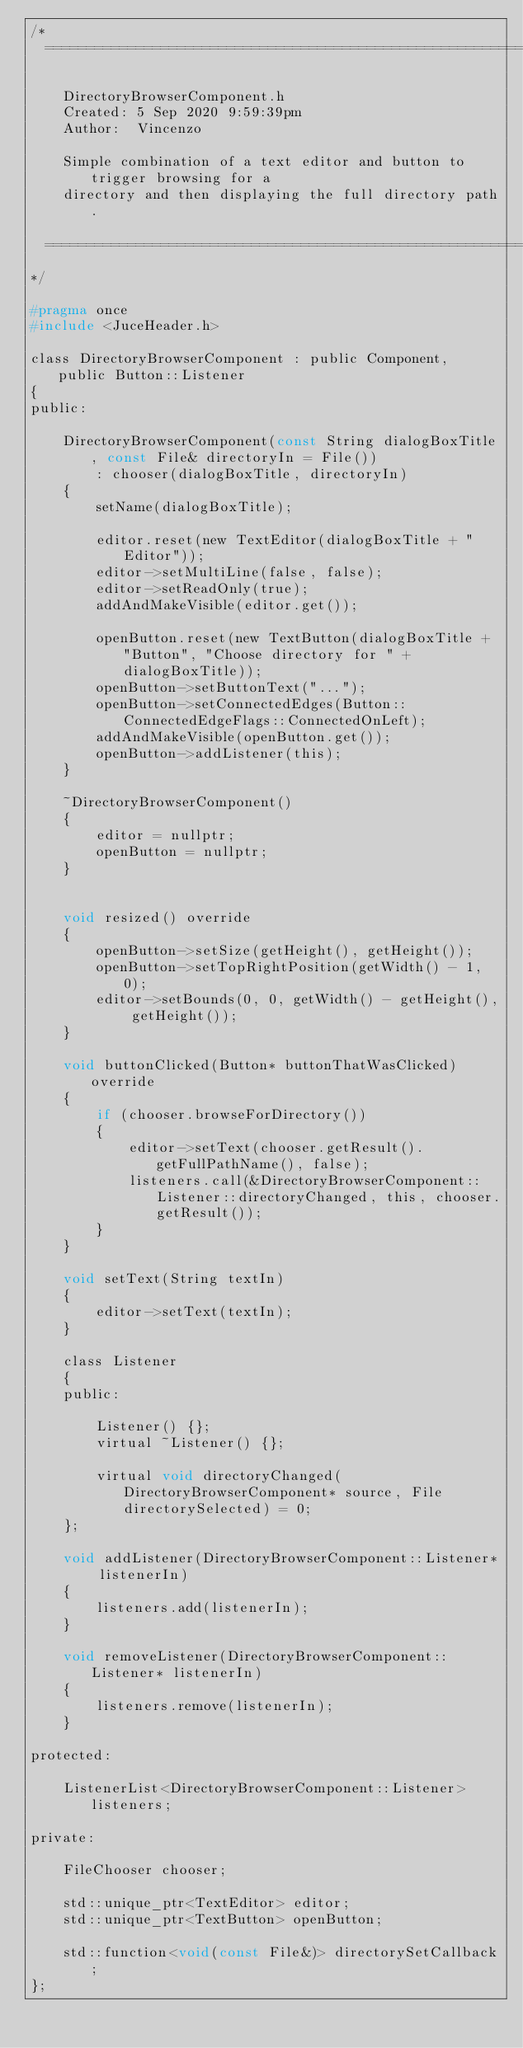Convert code to text. <code><loc_0><loc_0><loc_500><loc_500><_C_>/*
  ==============================================================================

    DirectoryBrowserComponent.h
    Created: 5 Sep 2020 9:59:39pm
    Author:  Vincenzo

    Simple combination of a text editor and button to trigger browsing for a 
    directory and then displaying the full directory path.

  ==============================================================================
*/

#pragma once
#include <JuceHeader.h>

class DirectoryBrowserComponent : public Component, public Button::Listener
{
public:

    DirectoryBrowserComponent(const String dialogBoxTitle, const File& directoryIn = File())
        : chooser(dialogBoxTitle, directoryIn)
    {
        setName(dialogBoxTitle);

        editor.reset(new TextEditor(dialogBoxTitle + "Editor"));
        editor->setMultiLine(false, false);
        editor->setReadOnly(true);
        addAndMakeVisible(editor.get());

        openButton.reset(new TextButton(dialogBoxTitle + "Button", "Choose directory for " + dialogBoxTitle));
        openButton->setButtonText("...");
        openButton->setConnectedEdges(Button::ConnectedEdgeFlags::ConnectedOnLeft);
        addAndMakeVisible(openButton.get());
        openButton->addListener(this);
    }

    ~DirectoryBrowserComponent()
    {
        editor = nullptr;
        openButton = nullptr;
    }


    void resized() override
    {
        openButton->setSize(getHeight(), getHeight());
        openButton->setTopRightPosition(getWidth() - 1, 0);
        editor->setBounds(0, 0, getWidth() - getHeight(), getHeight());
    }

    void buttonClicked(Button* buttonThatWasClicked) override
    {
        if (chooser.browseForDirectory())
        {
            editor->setText(chooser.getResult().getFullPathName(), false);
            listeners.call(&DirectoryBrowserComponent::Listener::directoryChanged, this, chooser.getResult());
        }
    }

    void setText(String textIn)
    {
        editor->setText(textIn);
    }

    class Listener
    {
    public:
        
        Listener() {};
        virtual ~Listener() {};

        virtual void directoryChanged(DirectoryBrowserComponent* source, File directorySelected) = 0;
    };

    void addListener(DirectoryBrowserComponent::Listener* listenerIn)
    {
        listeners.add(listenerIn);
    }

    void removeListener(DirectoryBrowserComponent::Listener* listenerIn)
    {
        listeners.remove(listenerIn);
    }

protected:

    ListenerList<DirectoryBrowserComponent::Listener> listeners;

private:

    FileChooser chooser;

    std::unique_ptr<TextEditor> editor;
    std::unique_ptr<TextButton> openButton;

    std::function<void(const File&)> directorySetCallback;
};
</code> 